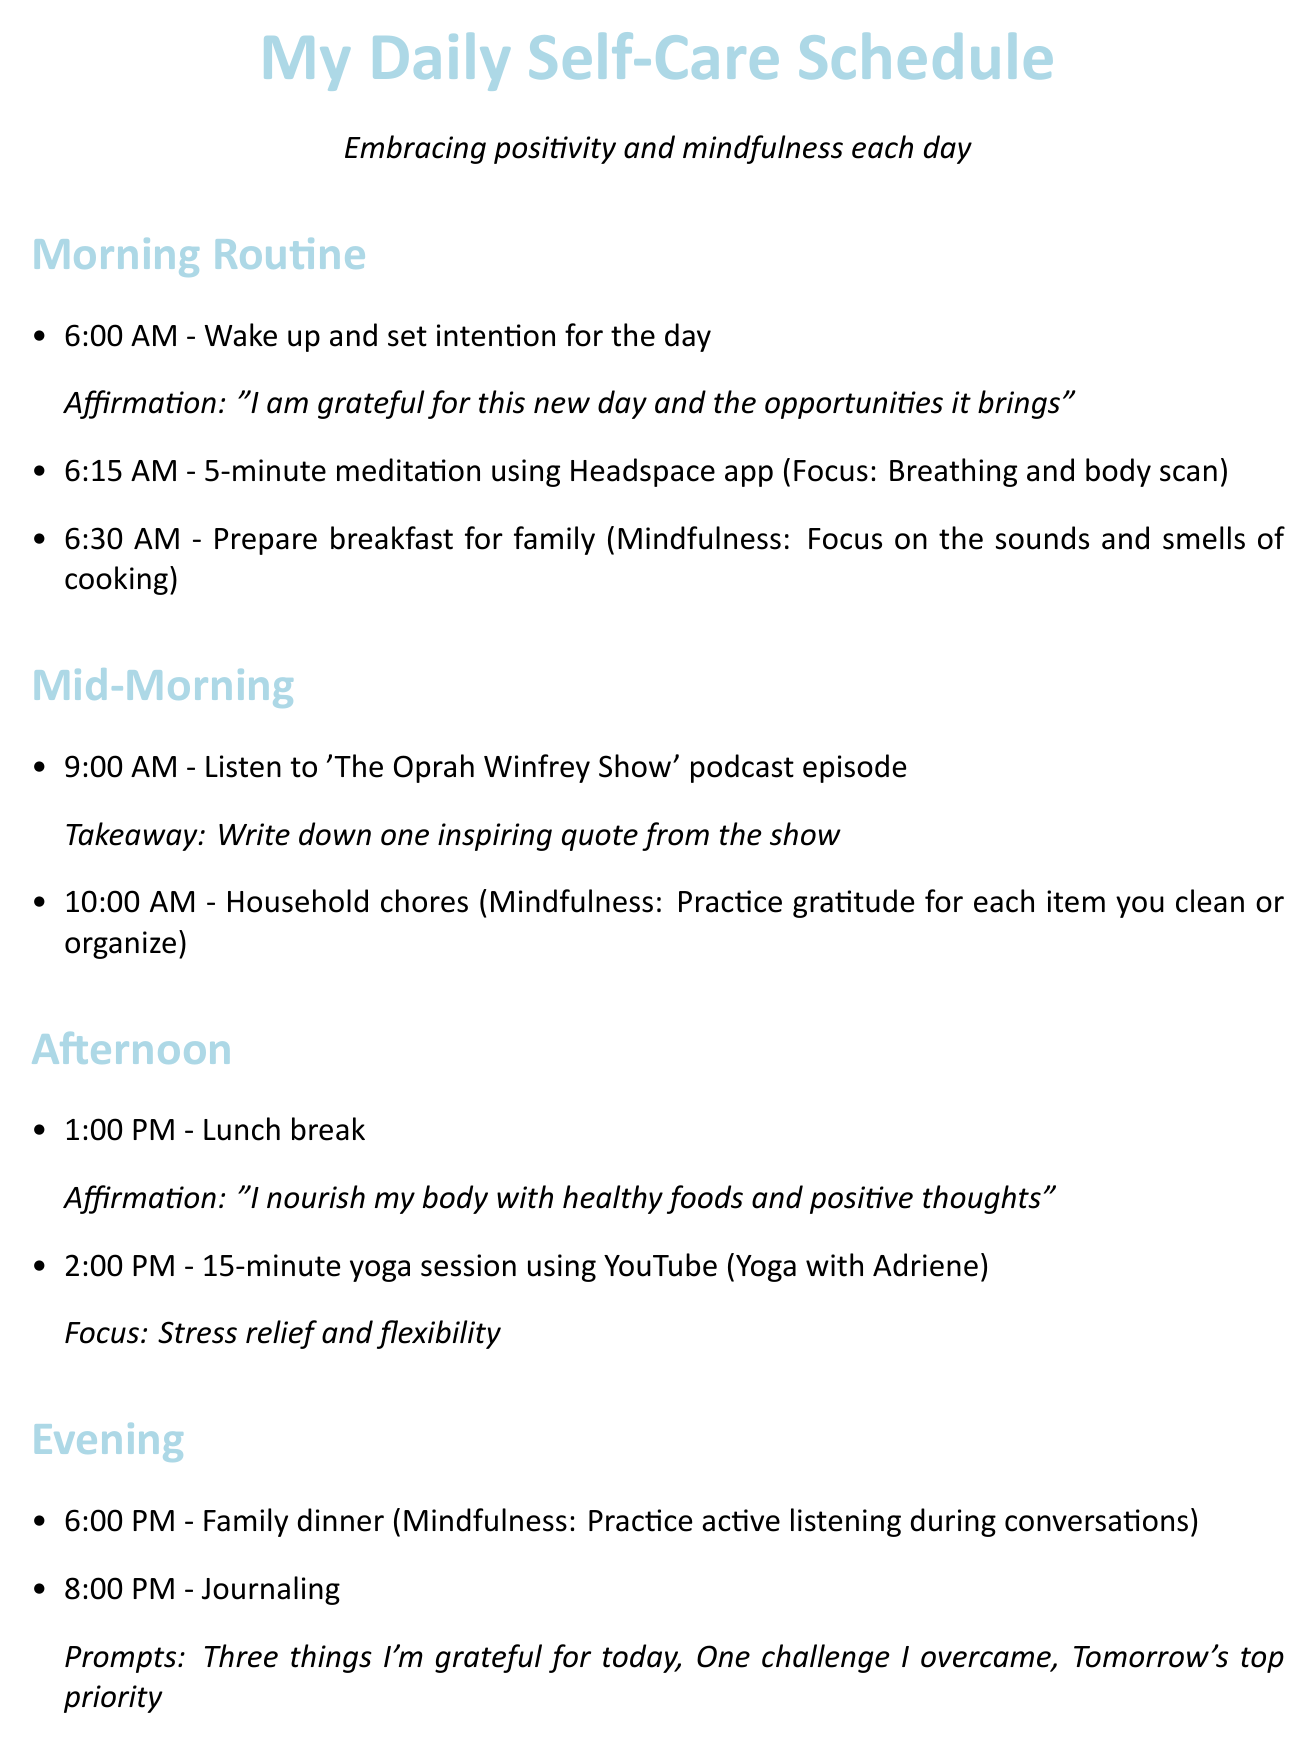What time do you wake up? The document states the time to wake up as part of the morning routine.
Answer: 6:00 AM What is the affirmation for the lunch break? The document provides an affirmation to be used during the lunch break at 1:00 PM.
Answer: I nourish my body with healthy foods and positive thoughts Which podcast do you listen to on Wednesday? The document specifies a podcast episode mentioned for Wednesday's activity at 2:00 PM.
Answer: The Happiness Lab What activity is scheduled for Friday at 8:30 PM? The document details the self-care activity planned for Friday evening.
Answer: Self-care bubble bath What mindfulness practice is suggested during family dinner? The document includes a mindfulness practice during the evening family dinner activity.
Answer: Practice active listening during conversations How long is the meditation session in the morning? The document specifies the duration of the meditation activity included in the morning routine.
Answer: 5 minutes What day do you attend the virtual mom support group? The document indicates the day for the virtual mom support group as part of weekly activities.
Answer: Monday What is the chosen reading material for bedtime? The document lists the current book for bedtime reading.
Answer: The Power of Now by Eckhart Tolle What time is journaling scheduled? The document identifies the specific time when journaling occurs during the evening routine.
Answer: 8:00 PM 